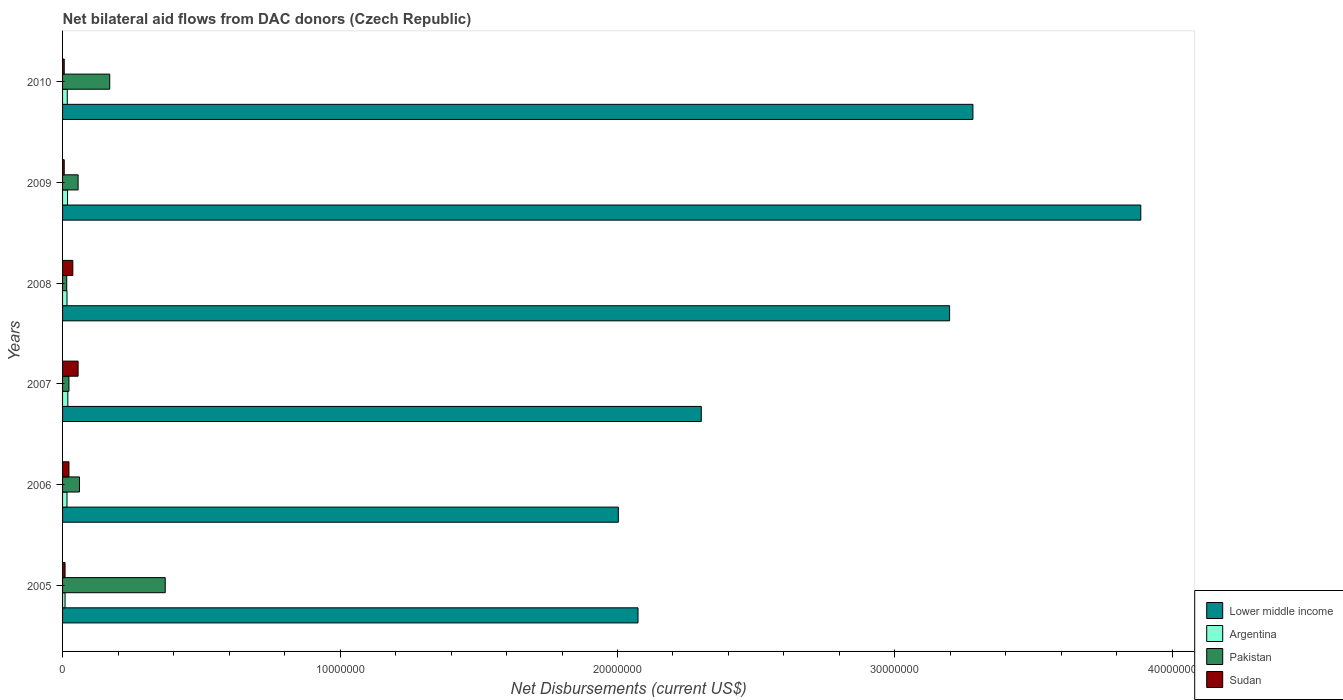How many bars are there on the 5th tick from the bottom?
Provide a short and direct response. 4. What is the net bilateral aid flows in Sudan in 2008?
Provide a short and direct response. 3.70e+05. Across all years, what is the maximum net bilateral aid flows in Sudan?
Make the answer very short. 5.60e+05. Across all years, what is the minimum net bilateral aid flows in Lower middle income?
Your response must be concise. 2.00e+07. What is the total net bilateral aid flows in Argentina in the graph?
Your answer should be compact. 9.50e+05. What is the difference between the net bilateral aid flows in Lower middle income in 2007 and that in 2010?
Give a very brief answer. -9.79e+06. What is the difference between the net bilateral aid flows in Sudan in 2006 and the net bilateral aid flows in Argentina in 2008?
Your answer should be compact. 7.00e+04. What is the average net bilateral aid flows in Lower middle income per year?
Your answer should be compact. 2.79e+07. In the year 2007, what is the difference between the net bilateral aid flows in Sudan and net bilateral aid flows in Pakistan?
Your answer should be compact. 3.30e+05. In how many years, is the net bilateral aid flows in Argentina greater than 12000000 US$?
Ensure brevity in your answer.  0. What is the ratio of the net bilateral aid flows in Lower middle income in 2007 to that in 2008?
Your answer should be compact. 0.72. Is the difference between the net bilateral aid flows in Sudan in 2009 and 2010 greater than the difference between the net bilateral aid flows in Pakistan in 2009 and 2010?
Your answer should be compact. Yes. What is the difference between the highest and the lowest net bilateral aid flows in Sudan?
Make the answer very short. 5.00e+05. In how many years, is the net bilateral aid flows in Sudan greater than the average net bilateral aid flows in Sudan taken over all years?
Provide a short and direct response. 3. Is the sum of the net bilateral aid flows in Argentina in 2007 and 2009 greater than the maximum net bilateral aid flows in Pakistan across all years?
Your response must be concise. No. Is it the case that in every year, the sum of the net bilateral aid flows in Lower middle income and net bilateral aid flows in Sudan is greater than the sum of net bilateral aid flows in Argentina and net bilateral aid flows in Pakistan?
Ensure brevity in your answer.  Yes. What does the 4th bar from the top in 2009 represents?
Give a very brief answer. Lower middle income. What does the 1st bar from the bottom in 2010 represents?
Provide a succinct answer. Lower middle income. Is it the case that in every year, the sum of the net bilateral aid flows in Pakistan and net bilateral aid flows in Lower middle income is greater than the net bilateral aid flows in Sudan?
Your response must be concise. Yes. Are all the bars in the graph horizontal?
Ensure brevity in your answer.  Yes. How many years are there in the graph?
Ensure brevity in your answer.  6. What is the difference between two consecutive major ticks on the X-axis?
Provide a succinct answer. 1.00e+07. Are the values on the major ticks of X-axis written in scientific E-notation?
Your response must be concise. No. Does the graph contain any zero values?
Offer a very short reply. No. Does the graph contain grids?
Give a very brief answer. No. Where does the legend appear in the graph?
Offer a terse response. Bottom right. How are the legend labels stacked?
Offer a very short reply. Vertical. What is the title of the graph?
Your answer should be very brief. Net bilateral aid flows from DAC donors (Czech Republic). What is the label or title of the X-axis?
Your answer should be compact. Net Disbursements (current US$). What is the label or title of the Y-axis?
Give a very brief answer. Years. What is the Net Disbursements (current US$) in Lower middle income in 2005?
Make the answer very short. 2.07e+07. What is the Net Disbursements (current US$) of Pakistan in 2005?
Provide a succinct answer. 3.70e+06. What is the Net Disbursements (current US$) in Lower middle income in 2006?
Offer a very short reply. 2.00e+07. What is the Net Disbursements (current US$) in Argentina in 2006?
Provide a succinct answer. 1.60e+05. What is the Net Disbursements (current US$) in Pakistan in 2006?
Your response must be concise. 6.10e+05. What is the Net Disbursements (current US$) of Lower middle income in 2007?
Your answer should be very brief. 2.30e+07. What is the Net Disbursements (current US$) of Sudan in 2007?
Make the answer very short. 5.60e+05. What is the Net Disbursements (current US$) in Lower middle income in 2008?
Offer a terse response. 3.20e+07. What is the Net Disbursements (current US$) in Lower middle income in 2009?
Provide a short and direct response. 3.89e+07. What is the Net Disbursements (current US$) in Argentina in 2009?
Your answer should be very brief. 1.80e+05. What is the Net Disbursements (current US$) of Pakistan in 2009?
Your answer should be very brief. 5.60e+05. What is the Net Disbursements (current US$) of Sudan in 2009?
Give a very brief answer. 6.00e+04. What is the Net Disbursements (current US$) in Lower middle income in 2010?
Your answer should be compact. 3.28e+07. What is the Net Disbursements (current US$) of Argentina in 2010?
Offer a very short reply. 1.70e+05. What is the Net Disbursements (current US$) of Pakistan in 2010?
Your response must be concise. 1.70e+06. Across all years, what is the maximum Net Disbursements (current US$) in Lower middle income?
Provide a succinct answer. 3.89e+07. Across all years, what is the maximum Net Disbursements (current US$) in Argentina?
Your response must be concise. 1.90e+05. Across all years, what is the maximum Net Disbursements (current US$) in Pakistan?
Give a very brief answer. 3.70e+06. Across all years, what is the maximum Net Disbursements (current US$) of Sudan?
Ensure brevity in your answer.  5.60e+05. Across all years, what is the minimum Net Disbursements (current US$) of Lower middle income?
Keep it short and to the point. 2.00e+07. Across all years, what is the minimum Net Disbursements (current US$) in Argentina?
Give a very brief answer. 9.00e+04. Across all years, what is the minimum Net Disbursements (current US$) in Pakistan?
Your answer should be compact. 1.50e+05. What is the total Net Disbursements (current US$) in Lower middle income in the graph?
Keep it short and to the point. 1.67e+08. What is the total Net Disbursements (current US$) of Argentina in the graph?
Keep it short and to the point. 9.50e+05. What is the total Net Disbursements (current US$) of Pakistan in the graph?
Your response must be concise. 6.95e+06. What is the total Net Disbursements (current US$) in Sudan in the graph?
Offer a terse response. 1.37e+06. What is the difference between the Net Disbursements (current US$) of Lower middle income in 2005 and that in 2006?
Offer a very short reply. 7.10e+05. What is the difference between the Net Disbursements (current US$) of Argentina in 2005 and that in 2006?
Ensure brevity in your answer.  -7.00e+04. What is the difference between the Net Disbursements (current US$) of Pakistan in 2005 and that in 2006?
Offer a very short reply. 3.09e+06. What is the difference between the Net Disbursements (current US$) in Sudan in 2005 and that in 2006?
Offer a very short reply. -1.40e+05. What is the difference between the Net Disbursements (current US$) in Lower middle income in 2005 and that in 2007?
Your answer should be compact. -2.28e+06. What is the difference between the Net Disbursements (current US$) of Pakistan in 2005 and that in 2007?
Provide a succinct answer. 3.47e+06. What is the difference between the Net Disbursements (current US$) in Sudan in 2005 and that in 2007?
Give a very brief answer. -4.70e+05. What is the difference between the Net Disbursements (current US$) of Lower middle income in 2005 and that in 2008?
Make the answer very short. -1.12e+07. What is the difference between the Net Disbursements (current US$) of Pakistan in 2005 and that in 2008?
Provide a succinct answer. 3.55e+06. What is the difference between the Net Disbursements (current US$) in Sudan in 2005 and that in 2008?
Keep it short and to the point. -2.80e+05. What is the difference between the Net Disbursements (current US$) of Lower middle income in 2005 and that in 2009?
Offer a terse response. -1.81e+07. What is the difference between the Net Disbursements (current US$) of Pakistan in 2005 and that in 2009?
Offer a terse response. 3.14e+06. What is the difference between the Net Disbursements (current US$) of Sudan in 2005 and that in 2009?
Keep it short and to the point. 3.00e+04. What is the difference between the Net Disbursements (current US$) in Lower middle income in 2005 and that in 2010?
Provide a succinct answer. -1.21e+07. What is the difference between the Net Disbursements (current US$) of Argentina in 2005 and that in 2010?
Offer a very short reply. -8.00e+04. What is the difference between the Net Disbursements (current US$) in Sudan in 2005 and that in 2010?
Ensure brevity in your answer.  3.00e+04. What is the difference between the Net Disbursements (current US$) in Lower middle income in 2006 and that in 2007?
Your response must be concise. -2.99e+06. What is the difference between the Net Disbursements (current US$) of Pakistan in 2006 and that in 2007?
Provide a short and direct response. 3.80e+05. What is the difference between the Net Disbursements (current US$) of Sudan in 2006 and that in 2007?
Give a very brief answer. -3.30e+05. What is the difference between the Net Disbursements (current US$) in Lower middle income in 2006 and that in 2008?
Offer a very short reply. -1.19e+07. What is the difference between the Net Disbursements (current US$) of Argentina in 2006 and that in 2008?
Offer a very short reply. 0. What is the difference between the Net Disbursements (current US$) of Pakistan in 2006 and that in 2008?
Offer a terse response. 4.60e+05. What is the difference between the Net Disbursements (current US$) of Lower middle income in 2006 and that in 2009?
Your response must be concise. -1.88e+07. What is the difference between the Net Disbursements (current US$) of Pakistan in 2006 and that in 2009?
Your answer should be compact. 5.00e+04. What is the difference between the Net Disbursements (current US$) in Sudan in 2006 and that in 2009?
Provide a succinct answer. 1.70e+05. What is the difference between the Net Disbursements (current US$) of Lower middle income in 2006 and that in 2010?
Give a very brief answer. -1.28e+07. What is the difference between the Net Disbursements (current US$) in Argentina in 2006 and that in 2010?
Your answer should be very brief. -10000. What is the difference between the Net Disbursements (current US$) in Pakistan in 2006 and that in 2010?
Your answer should be compact. -1.09e+06. What is the difference between the Net Disbursements (current US$) in Lower middle income in 2007 and that in 2008?
Offer a very short reply. -8.95e+06. What is the difference between the Net Disbursements (current US$) of Argentina in 2007 and that in 2008?
Your answer should be very brief. 3.00e+04. What is the difference between the Net Disbursements (current US$) in Pakistan in 2007 and that in 2008?
Provide a short and direct response. 8.00e+04. What is the difference between the Net Disbursements (current US$) of Lower middle income in 2007 and that in 2009?
Provide a short and direct response. -1.58e+07. What is the difference between the Net Disbursements (current US$) in Pakistan in 2007 and that in 2009?
Offer a terse response. -3.30e+05. What is the difference between the Net Disbursements (current US$) of Sudan in 2007 and that in 2009?
Provide a succinct answer. 5.00e+05. What is the difference between the Net Disbursements (current US$) in Lower middle income in 2007 and that in 2010?
Offer a terse response. -9.79e+06. What is the difference between the Net Disbursements (current US$) in Argentina in 2007 and that in 2010?
Your answer should be very brief. 2.00e+04. What is the difference between the Net Disbursements (current US$) in Pakistan in 2007 and that in 2010?
Offer a very short reply. -1.47e+06. What is the difference between the Net Disbursements (current US$) of Sudan in 2007 and that in 2010?
Provide a succinct answer. 5.00e+05. What is the difference between the Net Disbursements (current US$) of Lower middle income in 2008 and that in 2009?
Your answer should be compact. -6.89e+06. What is the difference between the Net Disbursements (current US$) of Argentina in 2008 and that in 2009?
Give a very brief answer. -2.00e+04. What is the difference between the Net Disbursements (current US$) of Pakistan in 2008 and that in 2009?
Provide a succinct answer. -4.10e+05. What is the difference between the Net Disbursements (current US$) of Lower middle income in 2008 and that in 2010?
Give a very brief answer. -8.40e+05. What is the difference between the Net Disbursements (current US$) in Argentina in 2008 and that in 2010?
Your answer should be very brief. -10000. What is the difference between the Net Disbursements (current US$) in Pakistan in 2008 and that in 2010?
Keep it short and to the point. -1.55e+06. What is the difference between the Net Disbursements (current US$) of Lower middle income in 2009 and that in 2010?
Make the answer very short. 6.05e+06. What is the difference between the Net Disbursements (current US$) of Argentina in 2009 and that in 2010?
Provide a succinct answer. 10000. What is the difference between the Net Disbursements (current US$) of Pakistan in 2009 and that in 2010?
Your answer should be very brief. -1.14e+06. What is the difference between the Net Disbursements (current US$) of Lower middle income in 2005 and the Net Disbursements (current US$) of Argentina in 2006?
Your response must be concise. 2.06e+07. What is the difference between the Net Disbursements (current US$) of Lower middle income in 2005 and the Net Disbursements (current US$) of Pakistan in 2006?
Provide a short and direct response. 2.01e+07. What is the difference between the Net Disbursements (current US$) of Lower middle income in 2005 and the Net Disbursements (current US$) of Sudan in 2006?
Make the answer very short. 2.05e+07. What is the difference between the Net Disbursements (current US$) of Argentina in 2005 and the Net Disbursements (current US$) of Pakistan in 2006?
Give a very brief answer. -5.20e+05. What is the difference between the Net Disbursements (current US$) of Argentina in 2005 and the Net Disbursements (current US$) of Sudan in 2006?
Your answer should be very brief. -1.40e+05. What is the difference between the Net Disbursements (current US$) in Pakistan in 2005 and the Net Disbursements (current US$) in Sudan in 2006?
Your answer should be compact. 3.47e+06. What is the difference between the Net Disbursements (current US$) of Lower middle income in 2005 and the Net Disbursements (current US$) of Argentina in 2007?
Ensure brevity in your answer.  2.06e+07. What is the difference between the Net Disbursements (current US$) of Lower middle income in 2005 and the Net Disbursements (current US$) of Pakistan in 2007?
Offer a very short reply. 2.05e+07. What is the difference between the Net Disbursements (current US$) of Lower middle income in 2005 and the Net Disbursements (current US$) of Sudan in 2007?
Your response must be concise. 2.02e+07. What is the difference between the Net Disbursements (current US$) in Argentina in 2005 and the Net Disbursements (current US$) in Sudan in 2007?
Make the answer very short. -4.70e+05. What is the difference between the Net Disbursements (current US$) of Pakistan in 2005 and the Net Disbursements (current US$) of Sudan in 2007?
Make the answer very short. 3.14e+06. What is the difference between the Net Disbursements (current US$) of Lower middle income in 2005 and the Net Disbursements (current US$) of Argentina in 2008?
Keep it short and to the point. 2.06e+07. What is the difference between the Net Disbursements (current US$) of Lower middle income in 2005 and the Net Disbursements (current US$) of Pakistan in 2008?
Your response must be concise. 2.06e+07. What is the difference between the Net Disbursements (current US$) in Lower middle income in 2005 and the Net Disbursements (current US$) in Sudan in 2008?
Your response must be concise. 2.04e+07. What is the difference between the Net Disbursements (current US$) in Argentina in 2005 and the Net Disbursements (current US$) in Sudan in 2008?
Your answer should be very brief. -2.80e+05. What is the difference between the Net Disbursements (current US$) of Pakistan in 2005 and the Net Disbursements (current US$) of Sudan in 2008?
Your answer should be very brief. 3.33e+06. What is the difference between the Net Disbursements (current US$) of Lower middle income in 2005 and the Net Disbursements (current US$) of Argentina in 2009?
Provide a short and direct response. 2.06e+07. What is the difference between the Net Disbursements (current US$) of Lower middle income in 2005 and the Net Disbursements (current US$) of Pakistan in 2009?
Keep it short and to the point. 2.02e+07. What is the difference between the Net Disbursements (current US$) in Lower middle income in 2005 and the Net Disbursements (current US$) in Sudan in 2009?
Keep it short and to the point. 2.07e+07. What is the difference between the Net Disbursements (current US$) of Argentina in 2005 and the Net Disbursements (current US$) of Pakistan in 2009?
Give a very brief answer. -4.70e+05. What is the difference between the Net Disbursements (current US$) of Pakistan in 2005 and the Net Disbursements (current US$) of Sudan in 2009?
Your answer should be very brief. 3.64e+06. What is the difference between the Net Disbursements (current US$) of Lower middle income in 2005 and the Net Disbursements (current US$) of Argentina in 2010?
Offer a very short reply. 2.06e+07. What is the difference between the Net Disbursements (current US$) of Lower middle income in 2005 and the Net Disbursements (current US$) of Pakistan in 2010?
Your answer should be very brief. 1.90e+07. What is the difference between the Net Disbursements (current US$) of Lower middle income in 2005 and the Net Disbursements (current US$) of Sudan in 2010?
Your response must be concise. 2.07e+07. What is the difference between the Net Disbursements (current US$) in Argentina in 2005 and the Net Disbursements (current US$) in Pakistan in 2010?
Your answer should be very brief. -1.61e+06. What is the difference between the Net Disbursements (current US$) of Argentina in 2005 and the Net Disbursements (current US$) of Sudan in 2010?
Offer a very short reply. 3.00e+04. What is the difference between the Net Disbursements (current US$) of Pakistan in 2005 and the Net Disbursements (current US$) of Sudan in 2010?
Provide a short and direct response. 3.64e+06. What is the difference between the Net Disbursements (current US$) in Lower middle income in 2006 and the Net Disbursements (current US$) in Argentina in 2007?
Your answer should be very brief. 1.98e+07. What is the difference between the Net Disbursements (current US$) of Lower middle income in 2006 and the Net Disbursements (current US$) of Pakistan in 2007?
Your response must be concise. 1.98e+07. What is the difference between the Net Disbursements (current US$) in Lower middle income in 2006 and the Net Disbursements (current US$) in Sudan in 2007?
Your response must be concise. 1.95e+07. What is the difference between the Net Disbursements (current US$) of Argentina in 2006 and the Net Disbursements (current US$) of Pakistan in 2007?
Your response must be concise. -7.00e+04. What is the difference between the Net Disbursements (current US$) in Argentina in 2006 and the Net Disbursements (current US$) in Sudan in 2007?
Your answer should be very brief. -4.00e+05. What is the difference between the Net Disbursements (current US$) in Lower middle income in 2006 and the Net Disbursements (current US$) in Argentina in 2008?
Keep it short and to the point. 1.99e+07. What is the difference between the Net Disbursements (current US$) in Lower middle income in 2006 and the Net Disbursements (current US$) in Pakistan in 2008?
Give a very brief answer. 1.99e+07. What is the difference between the Net Disbursements (current US$) of Lower middle income in 2006 and the Net Disbursements (current US$) of Sudan in 2008?
Give a very brief answer. 1.97e+07. What is the difference between the Net Disbursements (current US$) in Argentina in 2006 and the Net Disbursements (current US$) in Sudan in 2008?
Ensure brevity in your answer.  -2.10e+05. What is the difference between the Net Disbursements (current US$) in Pakistan in 2006 and the Net Disbursements (current US$) in Sudan in 2008?
Offer a very short reply. 2.40e+05. What is the difference between the Net Disbursements (current US$) of Lower middle income in 2006 and the Net Disbursements (current US$) of Argentina in 2009?
Your response must be concise. 1.98e+07. What is the difference between the Net Disbursements (current US$) in Lower middle income in 2006 and the Net Disbursements (current US$) in Pakistan in 2009?
Your answer should be very brief. 1.95e+07. What is the difference between the Net Disbursements (current US$) in Lower middle income in 2006 and the Net Disbursements (current US$) in Sudan in 2009?
Keep it short and to the point. 2.00e+07. What is the difference between the Net Disbursements (current US$) in Argentina in 2006 and the Net Disbursements (current US$) in Pakistan in 2009?
Offer a terse response. -4.00e+05. What is the difference between the Net Disbursements (current US$) in Argentina in 2006 and the Net Disbursements (current US$) in Sudan in 2009?
Your answer should be very brief. 1.00e+05. What is the difference between the Net Disbursements (current US$) in Lower middle income in 2006 and the Net Disbursements (current US$) in Argentina in 2010?
Ensure brevity in your answer.  1.99e+07. What is the difference between the Net Disbursements (current US$) of Lower middle income in 2006 and the Net Disbursements (current US$) of Pakistan in 2010?
Offer a terse response. 1.83e+07. What is the difference between the Net Disbursements (current US$) in Lower middle income in 2006 and the Net Disbursements (current US$) in Sudan in 2010?
Your answer should be very brief. 2.00e+07. What is the difference between the Net Disbursements (current US$) of Argentina in 2006 and the Net Disbursements (current US$) of Pakistan in 2010?
Provide a succinct answer. -1.54e+06. What is the difference between the Net Disbursements (current US$) in Argentina in 2006 and the Net Disbursements (current US$) in Sudan in 2010?
Offer a very short reply. 1.00e+05. What is the difference between the Net Disbursements (current US$) in Pakistan in 2006 and the Net Disbursements (current US$) in Sudan in 2010?
Offer a terse response. 5.50e+05. What is the difference between the Net Disbursements (current US$) in Lower middle income in 2007 and the Net Disbursements (current US$) in Argentina in 2008?
Your response must be concise. 2.29e+07. What is the difference between the Net Disbursements (current US$) in Lower middle income in 2007 and the Net Disbursements (current US$) in Pakistan in 2008?
Your answer should be compact. 2.29e+07. What is the difference between the Net Disbursements (current US$) in Lower middle income in 2007 and the Net Disbursements (current US$) in Sudan in 2008?
Provide a short and direct response. 2.26e+07. What is the difference between the Net Disbursements (current US$) of Argentina in 2007 and the Net Disbursements (current US$) of Pakistan in 2008?
Keep it short and to the point. 4.00e+04. What is the difference between the Net Disbursements (current US$) of Argentina in 2007 and the Net Disbursements (current US$) of Sudan in 2008?
Provide a succinct answer. -1.80e+05. What is the difference between the Net Disbursements (current US$) in Lower middle income in 2007 and the Net Disbursements (current US$) in Argentina in 2009?
Keep it short and to the point. 2.28e+07. What is the difference between the Net Disbursements (current US$) of Lower middle income in 2007 and the Net Disbursements (current US$) of Pakistan in 2009?
Provide a short and direct response. 2.25e+07. What is the difference between the Net Disbursements (current US$) of Lower middle income in 2007 and the Net Disbursements (current US$) of Sudan in 2009?
Your answer should be very brief. 2.30e+07. What is the difference between the Net Disbursements (current US$) in Argentina in 2007 and the Net Disbursements (current US$) in Pakistan in 2009?
Give a very brief answer. -3.70e+05. What is the difference between the Net Disbursements (current US$) in Lower middle income in 2007 and the Net Disbursements (current US$) in Argentina in 2010?
Your answer should be very brief. 2.28e+07. What is the difference between the Net Disbursements (current US$) in Lower middle income in 2007 and the Net Disbursements (current US$) in Pakistan in 2010?
Provide a short and direct response. 2.13e+07. What is the difference between the Net Disbursements (current US$) of Lower middle income in 2007 and the Net Disbursements (current US$) of Sudan in 2010?
Offer a terse response. 2.30e+07. What is the difference between the Net Disbursements (current US$) of Argentina in 2007 and the Net Disbursements (current US$) of Pakistan in 2010?
Provide a short and direct response. -1.51e+06. What is the difference between the Net Disbursements (current US$) of Argentina in 2007 and the Net Disbursements (current US$) of Sudan in 2010?
Give a very brief answer. 1.30e+05. What is the difference between the Net Disbursements (current US$) of Pakistan in 2007 and the Net Disbursements (current US$) of Sudan in 2010?
Your answer should be compact. 1.70e+05. What is the difference between the Net Disbursements (current US$) of Lower middle income in 2008 and the Net Disbursements (current US$) of Argentina in 2009?
Offer a very short reply. 3.18e+07. What is the difference between the Net Disbursements (current US$) of Lower middle income in 2008 and the Net Disbursements (current US$) of Pakistan in 2009?
Your answer should be very brief. 3.14e+07. What is the difference between the Net Disbursements (current US$) of Lower middle income in 2008 and the Net Disbursements (current US$) of Sudan in 2009?
Provide a short and direct response. 3.19e+07. What is the difference between the Net Disbursements (current US$) of Argentina in 2008 and the Net Disbursements (current US$) of Pakistan in 2009?
Give a very brief answer. -4.00e+05. What is the difference between the Net Disbursements (current US$) of Pakistan in 2008 and the Net Disbursements (current US$) of Sudan in 2009?
Offer a very short reply. 9.00e+04. What is the difference between the Net Disbursements (current US$) of Lower middle income in 2008 and the Net Disbursements (current US$) of Argentina in 2010?
Give a very brief answer. 3.18e+07. What is the difference between the Net Disbursements (current US$) in Lower middle income in 2008 and the Net Disbursements (current US$) in Pakistan in 2010?
Offer a very short reply. 3.03e+07. What is the difference between the Net Disbursements (current US$) in Lower middle income in 2008 and the Net Disbursements (current US$) in Sudan in 2010?
Keep it short and to the point. 3.19e+07. What is the difference between the Net Disbursements (current US$) of Argentina in 2008 and the Net Disbursements (current US$) of Pakistan in 2010?
Provide a short and direct response. -1.54e+06. What is the difference between the Net Disbursements (current US$) in Argentina in 2008 and the Net Disbursements (current US$) in Sudan in 2010?
Provide a succinct answer. 1.00e+05. What is the difference between the Net Disbursements (current US$) in Pakistan in 2008 and the Net Disbursements (current US$) in Sudan in 2010?
Provide a succinct answer. 9.00e+04. What is the difference between the Net Disbursements (current US$) of Lower middle income in 2009 and the Net Disbursements (current US$) of Argentina in 2010?
Provide a succinct answer. 3.87e+07. What is the difference between the Net Disbursements (current US$) in Lower middle income in 2009 and the Net Disbursements (current US$) in Pakistan in 2010?
Your response must be concise. 3.72e+07. What is the difference between the Net Disbursements (current US$) in Lower middle income in 2009 and the Net Disbursements (current US$) in Sudan in 2010?
Make the answer very short. 3.88e+07. What is the difference between the Net Disbursements (current US$) of Argentina in 2009 and the Net Disbursements (current US$) of Pakistan in 2010?
Provide a succinct answer. -1.52e+06. What is the difference between the Net Disbursements (current US$) in Argentina in 2009 and the Net Disbursements (current US$) in Sudan in 2010?
Keep it short and to the point. 1.20e+05. What is the difference between the Net Disbursements (current US$) in Pakistan in 2009 and the Net Disbursements (current US$) in Sudan in 2010?
Provide a short and direct response. 5.00e+05. What is the average Net Disbursements (current US$) of Lower middle income per year?
Make the answer very short. 2.79e+07. What is the average Net Disbursements (current US$) of Argentina per year?
Provide a short and direct response. 1.58e+05. What is the average Net Disbursements (current US$) in Pakistan per year?
Offer a terse response. 1.16e+06. What is the average Net Disbursements (current US$) of Sudan per year?
Offer a terse response. 2.28e+05. In the year 2005, what is the difference between the Net Disbursements (current US$) in Lower middle income and Net Disbursements (current US$) in Argentina?
Provide a short and direct response. 2.06e+07. In the year 2005, what is the difference between the Net Disbursements (current US$) of Lower middle income and Net Disbursements (current US$) of Pakistan?
Offer a very short reply. 1.70e+07. In the year 2005, what is the difference between the Net Disbursements (current US$) of Lower middle income and Net Disbursements (current US$) of Sudan?
Give a very brief answer. 2.06e+07. In the year 2005, what is the difference between the Net Disbursements (current US$) of Argentina and Net Disbursements (current US$) of Pakistan?
Give a very brief answer. -3.61e+06. In the year 2005, what is the difference between the Net Disbursements (current US$) of Pakistan and Net Disbursements (current US$) of Sudan?
Offer a very short reply. 3.61e+06. In the year 2006, what is the difference between the Net Disbursements (current US$) of Lower middle income and Net Disbursements (current US$) of Argentina?
Make the answer very short. 1.99e+07. In the year 2006, what is the difference between the Net Disbursements (current US$) in Lower middle income and Net Disbursements (current US$) in Pakistan?
Your response must be concise. 1.94e+07. In the year 2006, what is the difference between the Net Disbursements (current US$) of Lower middle income and Net Disbursements (current US$) of Sudan?
Give a very brief answer. 1.98e+07. In the year 2006, what is the difference between the Net Disbursements (current US$) of Argentina and Net Disbursements (current US$) of Pakistan?
Your answer should be compact. -4.50e+05. In the year 2006, what is the difference between the Net Disbursements (current US$) of Pakistan and Net Disbursements (current US$) of Sudan?
Ensure brevity in your answer.  3.80e+05. In the year 2007, what is the difference between the Net Disbursements (current US$) in Lower middle income and Net Disbursements (current US$) in Argentina?
Provide a succinct answer. 2.28e+07. In the year 2007, what is the difference between the Net Disbursements (current US$) in Lower middle income and Net Disbursements (current US$) in Pakistan?
Provide a short and direct response. 2.28e+07. In the year 2007, what is the difference between the Net Disbursements (current US$) in Lower middle income and Net Disbursements (current US$) in Sudan?
Provide a succinct answer. 2.25e+07. In the year 2007, what is the difference between the Net Disbursements (current US$) of Argentina and Net Disbursements (current US$) of Pakistan?
Give a very brief answer. -4.00e+04. In the year 2007, what is the difference between the Net Disbursements (current US$) in Argentina and Net Disbursements (current US$) in Sudan?
Provide a short and direct response. -3.70e+05. In the year 2007, what is the difference between the Net Disbursements (current US$) of Pakistan and Net Disbursements (current US$) of Sudan?
Ensure brevity in your answer.  -3.30e+05. In the year 2008, what is the difference between the Net Disbursements (current US$) of Lower middle income and Net Disbursements (current US$) of Argentina?
Offer a very short reply. 3.18e+07. In the year 2008, what is the difference between the Net Disbursements (current US$) of Lower middle income and Net Disbursements (current US$) of Pakistan?
Offer a very short reply. 3.18e+07. In the year 2008, what is the difference between the Net Disbursements (current US$) of Lower middle income and Net Disbursements (current US$) of Sudan?
Your answer should be compact. 3.16e+07. In the year 2008, what is the difference between the Net Disbursements (current US$) in Pakistan and Net Disbursements (current US$) in Sudan?
Provide a succinct answer. -2.20e+05. In the year 2009, what is the difference between the Net Disbursements (current US$) of Lower middle income and Net Disbursements (current US$) of Argentina?
Provide a succinct answer. 3.87e+07. In the year 2009, what is the difference between the Net Disbursements (current US$) in Lower middle income and Net Disbursements (current US$) in Pakistan?
Offer a very short reply. 3.83e+07. In the year 2009, what is the difference between the Net Disbursements (current US$) in Lower middle income and Net Disbursements (current US$) in Sudan?
Your answer should be compact. 3.88e+07. In the year 2009, what is the difference between the Net Disbursements (current US$) of Argentina and Net Disbursements (current US$) of Pakistan?
Offer a very short reply. -3.80e+05. In the year 2009, what is the difference between the Net Disbursements (current US$) in Argentina and Net Disbursements (current US$) in Sudan?
Keep it short and to the point. 1.20e+05. In the year 2010, what is the difference between the Net Disbursements (current US$) in Lower middle income and Net Disbursements (current US$) in Argentina?
Offer a very short reply. 3.26e+07. In the year 2010, what is the difference between the Net Disbursements (current US$) in Lower middle income and Net Disbursements (current US$) in Pakistan?
Give a very brief answer. 3.11e+07. In the year 2010, what is the difference between the Net Disbursements (current US$) of Lower middle income and Net Disbursements (current US$) of Sudan?
Offer a terse response. 3.28e+07. In the year 2010, what is the difference between the Net Disbursements (current US$) of Argentina and Net Disbursements (current US$) of Pakistan?
Your response must be concise. -1.53e+06. In the year 2010, what is the difference between the Net Disbursements (current US$) of Argentina and Net Disbursements (current US$) of Sudan?
Provide a short and direct response. 1.10e+05. In the year 2010, what is the difference between the Net Disbursements (current US$) of Pakistan and Net Disbursements (current US$) of Sudan?
Offer a terse response. 1.64e+06. What is the ratio of the Net Disbursements (current US$) in Lower middle income in 2005 to that in 2006?
Offer a very short reply. 1.04. What is the ratio of the Net Disbursements (current US$) of Argentina in 2005 to that in 2006?
Your response must be concise. 0.56. What is the ratio of the Net Disbursements (current US$) of Pakistan in 2005 to that in 2006?
Offer a terse response. 6.07. What is the ratio of the Net Disbursements (current US$) in Sudan in 2005 to that in 2006?
Offer a terse response. 0.39. What is the ratio of the Net Disbursements (current US$) of Lower middle income in 2005 to that in 2007?
Provide a short and direct response. 0.9. What is the ratio of the Net Disbursements (current US$) of Argentina in 2005 to that in 2007?
Provide a succinct answer. 0.47. What is the ratio of the Net Disbursements (current US$) of Pakistan in 2005 to that in 2007?
Provide a short and direct response. 16.09. What is the ratio of the Net Disbursements (current US$) of Sudan in 2005 to that in 2007?
Provide a short and direct response. 0.16. What is the ratio of the Net Disbursements (current US$) in Lower middle income in 2005 to that in 2008?
Provide a succinct answer. 0.65. What is the ratio of the Net Disbursements (current US$) of Argentina in 2005 to that in 2008?
Ensure brevity in your answer.  0.56. What is the ratio of the Net Disbursements (current US$) in Pakistan in 2005 to that in 2008?
Offer a terse response. 24.67. What is the ratio of the Net Disbursements (current US$) in Sudan in 2005 to that in 2008?
Make the answer very short. 0.24. What is the ratio of the Net Disbursements (current US$) in Lower middle income in 2005 to that in 2009?
Your answer should be very brief. 0.53. What is the ratio of the Net Disbursements (current US$) of Pakistan in 2005 to that in 2009?
Ensure brevity in your answer.  6.61. What is the ratio of the Net Disbursements (current US$) of Sudan in 2005 to that in 2009?
Your answer should be very brief. 1.5. What is the ratio of the Net Disbursements (current US$) of Lower middle income in 2005 to that in 2010?
Give a very brief answer. 0.63. What is the ratio of the Net Disbursements (current US$) in Argentina in 2005 to that in 2010?
Provide a short and direct response. 0.53. What is the ratio of the Net Disbursements (current US$) in Pakistan in 2005 to that in 2010?
Keep it short and to the point. 2.18. What is the ratio of the Net Disbursements (current US$) in Sudan in 2005 to that in 2010?
Offer a terse response. 1.5. What is the ratio of the Net Disbursements (current US$) in Lower middle income in 2006 to that in 2007?
Ensure brevity in your answer.  0.87. What is the ratio of the Net Disbursements (current US$) of Argentina in 2006 to that in 2007?
Your answer should be compact. 0.84. What is the ratio of the Net Disbursements (current US$) in Pakistan in 2006 to that in 2007?
Offer a terse response. 2.65. What is the ratio of the Net Disbursements (current US$) in Sudan in 2006 to that in 2007?
Your response must be concise. 0.41. What is the ratio of the Net Disbursements (current US$) in Lower middle income in 2006 to that in 2008?
Your answer should be compact. 0.63. What is the ratio of the Net Disbursements (current US$) in Pakistan in 2006 to that in 2008?
Offer a terse response. 4.07. What is the ratio of the Net Disbursements (current US$) in Sudan in 2006 to that in 2008?
Offer a terse response. 0.62. What is the ratio of the Net Disbursements (current US$) of Lower middle income in 2006 to that in 2009?
Give a very brief answer. 0.52. What is the ratio of the Net Disbursements (current US$) in Argentina in 2006 to that in 2009?
Ensure brevity in your answer.  0.89. What is the ratio of the Net Disbursements (current US$) of Pakistan in 2006 to that in 2009?
Give a very brief answer. 1.09. What is the ratio of the Net Disbursements (current US$) in Sudan in 2006 to that in 2009?
Make the answer very short. 3.83. What is the ratio of the Net Disbursements (current US$) of Lower middle income in 2006 to that in 2010?
Offer a very short reply. 0.61. What is the ratio of the Net Disbursements (current US$) of Pakistan in 2006 to that in 2010?
Provide a succinct answer. 0.36. What is the ratio of the Net Disbursements (current US$) of Sudan in 2006 to that in 2010?
Give a very brief answer. 3.83. What is the ratio of the Net Disbursements (current US$) in Lower middle income in 2007 to that in 2008?
Keep it short and to the point. 0.72. What is the ratio of the Net Disbursements (current US$) in Argentina in 2007 to that in 2008?
Ensure brevity in your answer.  1.19. What is the ratio of the Net Disbursements (current US$) in Pakistan in 2007 to that in 2008?
Offer a very short reply. 1.53. What is the ratio of the Net Disbursements (current US$) in Sudan in 2007 to that in 2008?
Your answer should be very brief. 1.51. What is the ratio of the Net Disbursements (current US$) of Lower middle income in 2007 to that in 2009?
Ensure brevity in your answer.  0.59. What is the ratio of the Net Disbursements (current US$) of Argentina in 2007 to that in 2009?
Keep it short and to the point. 1.06. What is the ratio of the Net Disbursements (current US$) in Pakistan in 2007 to that in 2009?
Provide a short and direct response. 0.41. What is the ratio of the Net Disbursements (current US$) in Sudan in 2007 to that in 2009?
Provide a succinct answer. 9.33. What is the ratio of the Net Disbursements (current US$) of Lower middle income in 2007 to that in 2010?
Offer a terse response. 0.7. What is the ratio of the Net Disbursements (current US$) of Argentina in 2007 to that in 2010?
Your answer should be compact. 1.12. What is the ratio of the Net Disbursements (current US$) in Pakistan in 2007 to that in 2010?
Keep it short and to the point. 0.14. What is the ratio of the Net Disbursements (current US$) in Sudan in 2007 to that in 2010?
Offer a terse response. 9.33. What is the ratio of the Net Disbursements (current US$) in Lower middle income in 2008 to that in 2009?
Your answer should be compact. 0.82. What is the ratio of the Net Disbursements (current US$) of Argentina in 2008 to that in 2009?
Your response must be concise. 0.89. What is the ratio of the Net Disbursements (current US$) in Pakistan in 2008 to that in 2009?
Make the answer very short. 0.27. What is the ratio of the Net Disbursements (current US$) in Sudan in 2008 to that in 2009?
Give a very brief answer. 6.17. What is the ratio of the Net Disbursements (current US$) in Lower middle income in 2008 to that in 2010?
Your answer should be compact. 0.97. What is the ratio of the Net Disbursements (current US$) of Pakistan in 2008 to that in 2010?
Offer a very short reply. 0.09. What is the ratio of the Net Disbursements (current US$) of Sudan in 2008 to that in 2010?
Your answer should be very brief. 6.17. What is the ratio of the Net Disbursements (current US$) of Lower middle income in 2009 to that in 2010?
Provide a short and direct response. 1.18. What is the ratio of the Net Disbursements (current US$) of Argentina in 2009 to that in 2010?
Your answer should be compact. 1.06. What is the ratio of the Net Disbursements (current US$) of Pakistan in 2009 to that in 2010?
Offer a very short reply. 0.33. What is the difference between the highest and the second highest Net Disbursements (current US$) in Lower middle income?
Provide a short and direct response. 6.05e+06. What is the difference between the highest and the second highest Net Disbursements (current US$) of Argentina?
Your answer should be very brief. 10000. What is the difference between the highest and the second highest Net Disbursements (current US$) of Pakistan?
Offer a very short reply. 2.00e+06. What is the difference between the highest and the lowest Net Disbursements (current US$) of Lower middle income?
Provide a succinct answer. 1.88e+07. What is the difference between the highest and the lowest Net Disbursements (current US$) in Argentina?
Provide a succinct answer. 1.00e+05. What is the difference between the highest and the lowest Net Disbursements (current US$) in Pakistan?
Provide a short and direct response. 3.55e+06. What is the difference between the highest and the lowest Net Disbursements (current US$) of Sudan?
Provide a short and direct response. 5.00e+05. 